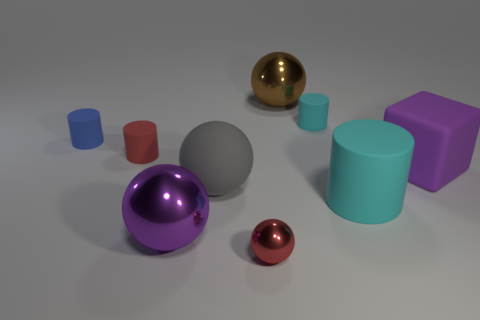How would you describe the mood or atmosphere this image creates? The image exudes a tranquil and clean aesthetic, largely due to the uncluttered background and the minimalist arrangement of the shapes. The soft lighting and the matte finish of the surfaces add to the serene mood. 